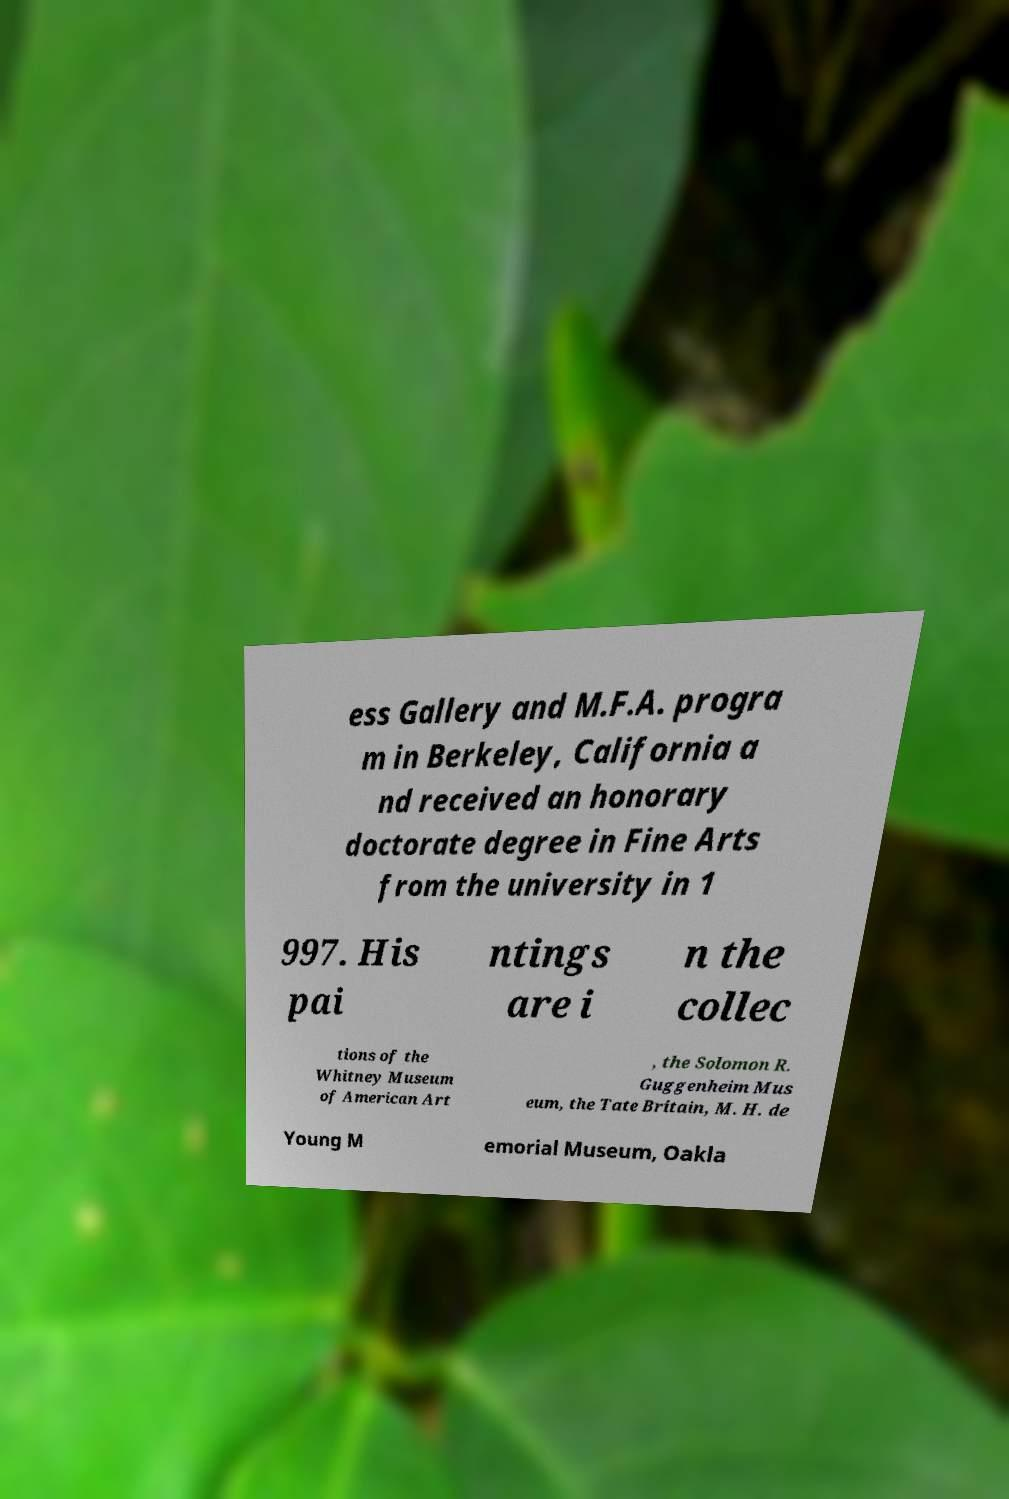Could you assist in decoding the text presented in this image and type it out clearly? ess Gallery and M.F.A. progra m in Berkeley, California a nd received an honorary doctorate degree in Fine Arts from the university in 1 997. His pai ntings are i n the collec tions of the Whitney Museum of American Art , the Solomon R. Guggenheim Mus eum, the Tate Britain, M. H. de Young M emorial Museum, Oakla 